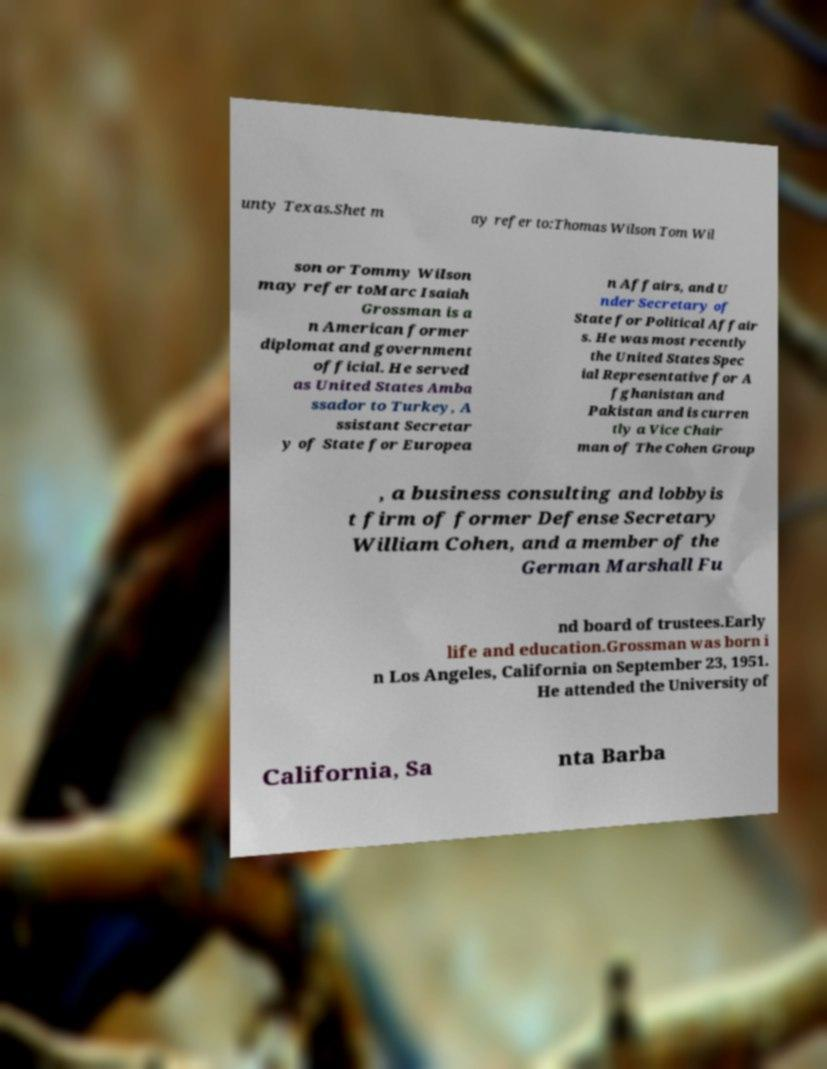I need the written content from this picture converted into text. Can you do that? unty Texas.Shet m ay refer to:Thomas Wilson Tom Wil son or Tommy Wilson may refer toMarc Isaiah Grossman is a n American former diplomat and government official. He served as United States Amba ssador to Turkey, A ssistant Secretar y of State for Europea n Affairs, and U nder Secretary of State for Political Affair s. He was most recently the United States Spec ial Representative for A fghanistan and Pakistan and is curren tly a Vice Chair man of The Cohen Group , a business consulting and lobbyis t firm of former Defense Secretary William Cohen, and a member of the German Marshall Fu nd board of trustees.Early life and education.Grossman was born i n Los Angeles, California on September 23, 1951. He attended the University of California, Sa nta Barba 